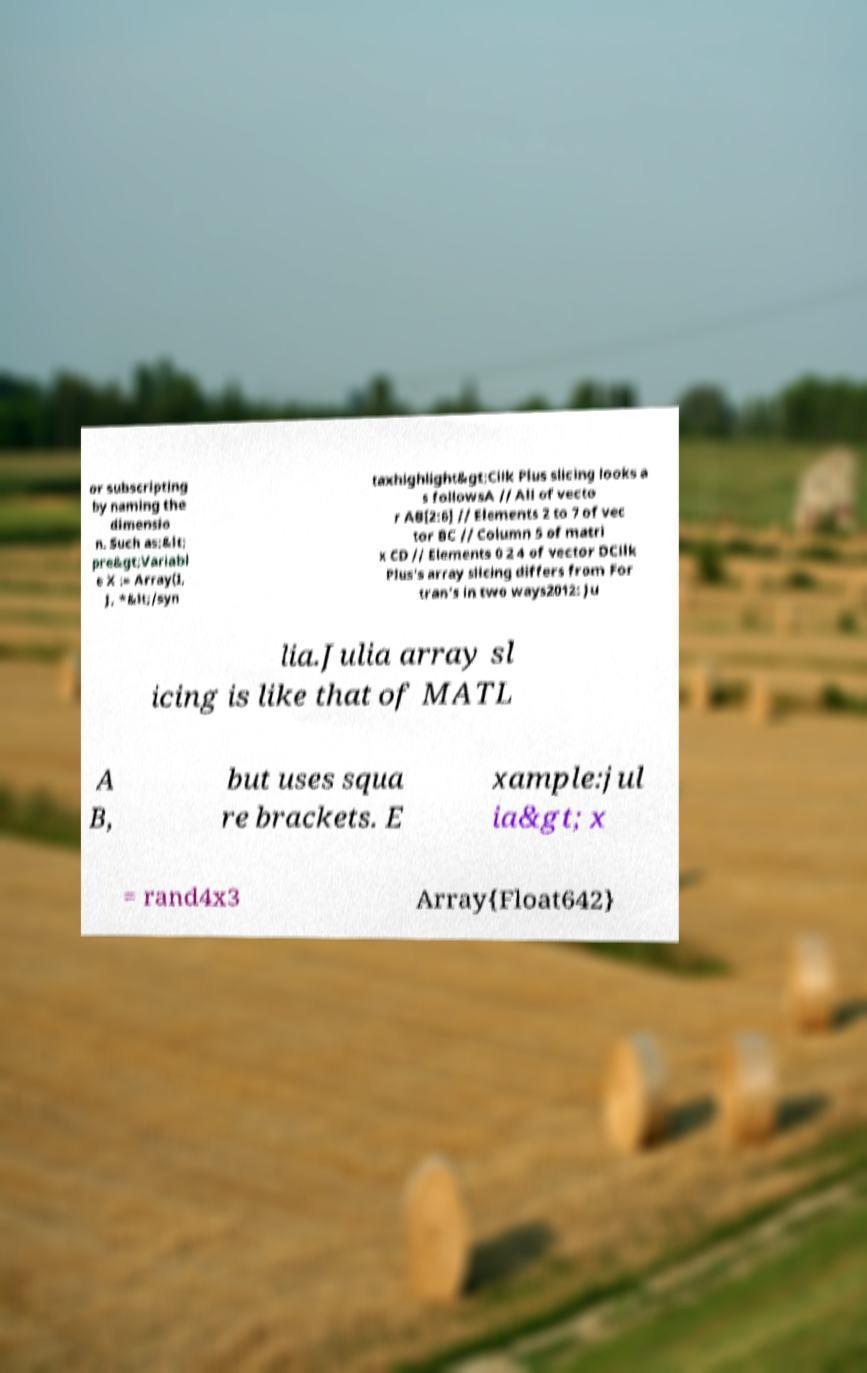For documentation purposes, I need the text within this image transcribed. Could you provide that? or subscripting by naming the dimensio n. Such as:&lt; pre&gt;Variabl e X := Array(I, J, *&lt;/syn taxhighlight&gt;Cilk Plus slicing looks a s followsA // All of vecto r AB[2:6] // Elements 2 to 7 of vec tor BC // Column 5 of matri x CD // Elements 0 2 4 of vector DCilk Plus's array slicing differs from For tran's in two ways2012: Ju lia.Julia array sl icing is like that of MATL A B, but uses squa re brackets. E xample:jul ia&gt; x = rand4x3 Array{Float642} 